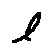Convert formula to latex. <formula><loc_0><loc_0><loc_500><loc_500>l</formula> 